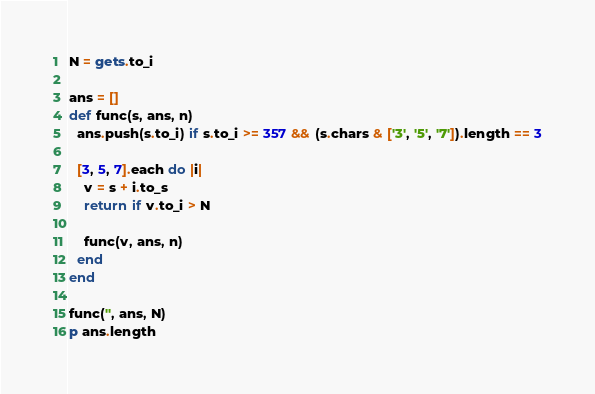Convert code to text. <code><loc_0><loc_0><loc_500><loc_500><_Ruby_>N = gets.to_i

ans = []
def func(s, ans, n)
  ans.push(s.to_i) if s.to_i >= 357 && (s.chars & ['3', '5', '7']).length == 3

  [3, 5, 7].each do |i|
    v = s + i.to_s
    return if v.to_i > N

    func(v, ans, n)
  end
end

func('', ans, N)
p ans.length
</code> 